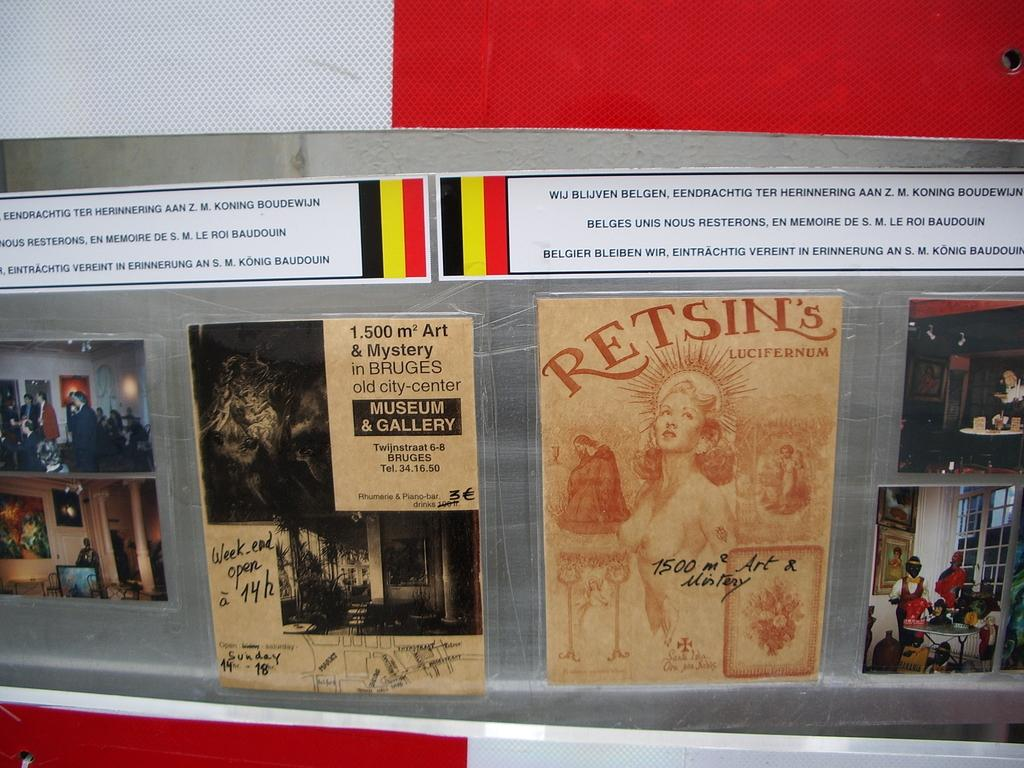<image>
Render a clear and concise summary of the photo. the word Retsins that has a silver background 